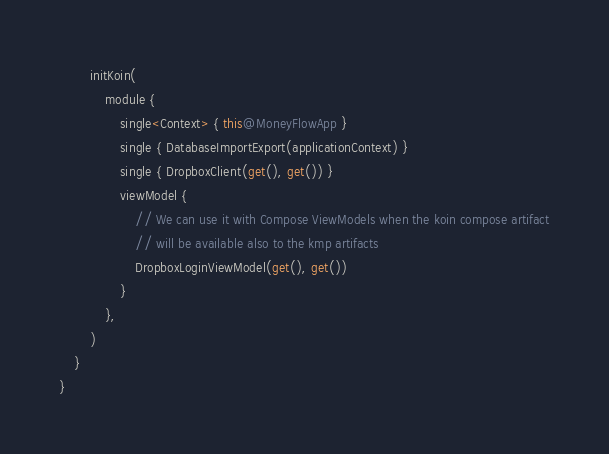<code> <loc_0><loc_0><loc_500><loc_500><_Kotlin_>
        initKoin(
            module {
                single<Context> { this@MoneyFlowApp }
                single { DatabaseImportExport(applicationContext) }
                single { DropboxClient(get(), get()) }
                viewModel {
                    // We can use it with Compose ViewModels when the koin compose artifact
                    // will be available also to the kmp artifacts
                    DropboxLoginViewModel(get(), get())
                }
            },
        )
    }
}</code> 